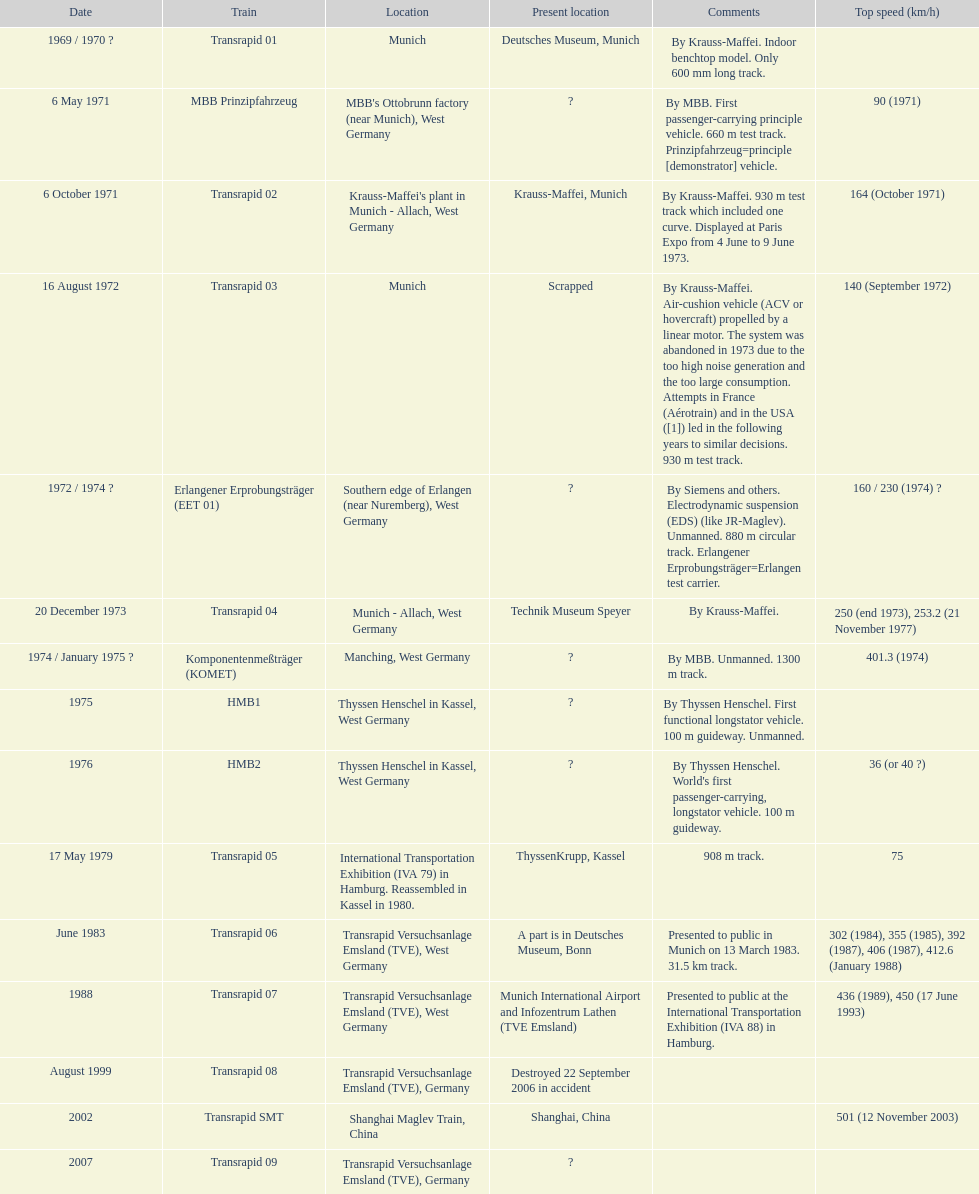Inform me of the quantity of versions that are discarded. 1. 